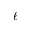<formula> <loc_0><loc_0><loc_500><loc_500>\ell</formula> 